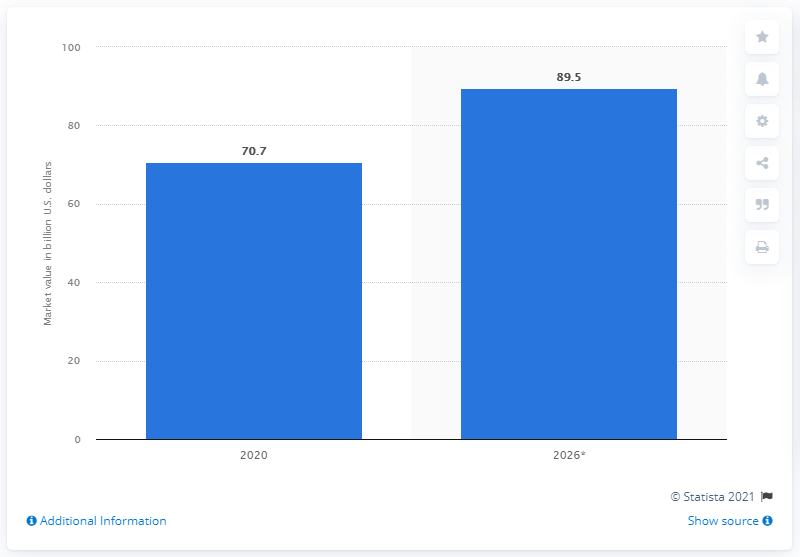Give some essential details in this illustration. The global HPDE market is valued at approximately 89.5 dollars. According to a 2020 market analysis, the global high-density polyethylene market was valued at approximately 70.7 billion dollars. 